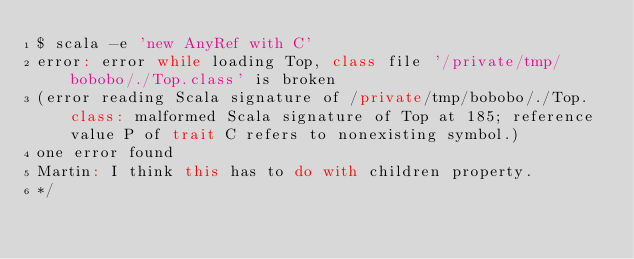Convert code to text. <code><loc_0><loc_0><loc_500><loc_500><_Scala_>$ scala -e 'new AnyRef with C'
error: error while loading Top, class file '/private/tmp/bobobo/./Top.class' is broken
(error reading Scala signature of /private/tmp/bobobo/./Top.class: malformed Scala signature of Top at 185; reference value P of trait C refers to nonexisting symbol.)
one error found
Martin: I think this has to do with children property.
*/
</code> 